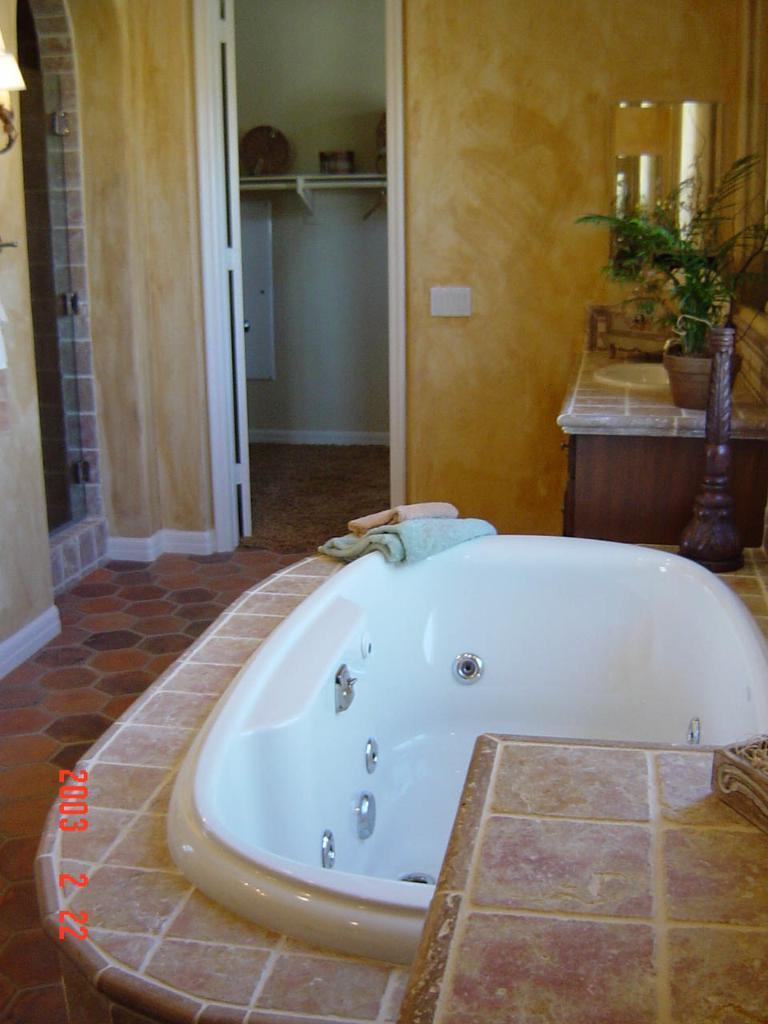What is the main object in the image? There is a bathtub in the image. What items are present for drying off after using the bathtub? There are towels in the image. How can someone enter the room where the bathtub is located? There is an entrance in the image. What is another fixture typically found in a bathroom? There is a sink in the image. What object might be used for planting flowers or other greenery? There is a planter pot in the image. What can be used for checking one's appearance or grooming? There is a mirror in the image. Can you see a robin perched on the edge of the bathtub in the image? No, there is no robin present in the image. Is there a kitten playing with a pencil in the image? No, there is no kitten or pencil present in the image. 